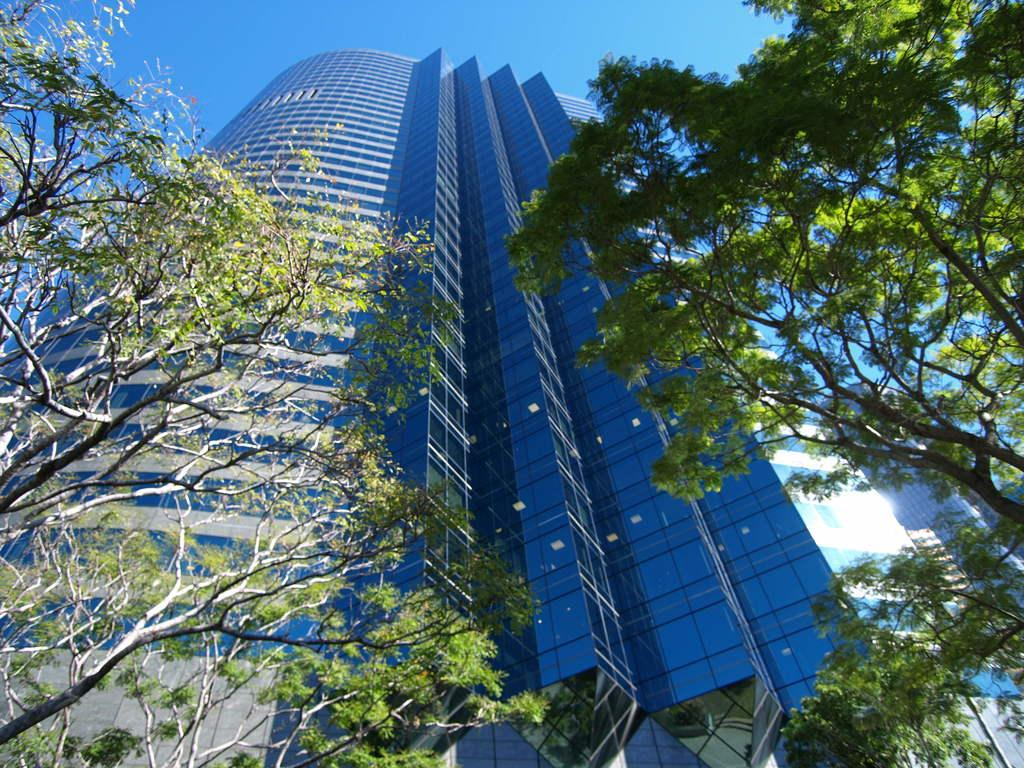What type of structure is present in the image? There is a building in the image. What other natural elements can be seen in the image? There are trees in the image. What can be seen in the distance in the image? The sky is visible in the background of the image. How many babies are holding a sign and a stick in the image? There are no babies, signs, or sticks present in the image. 